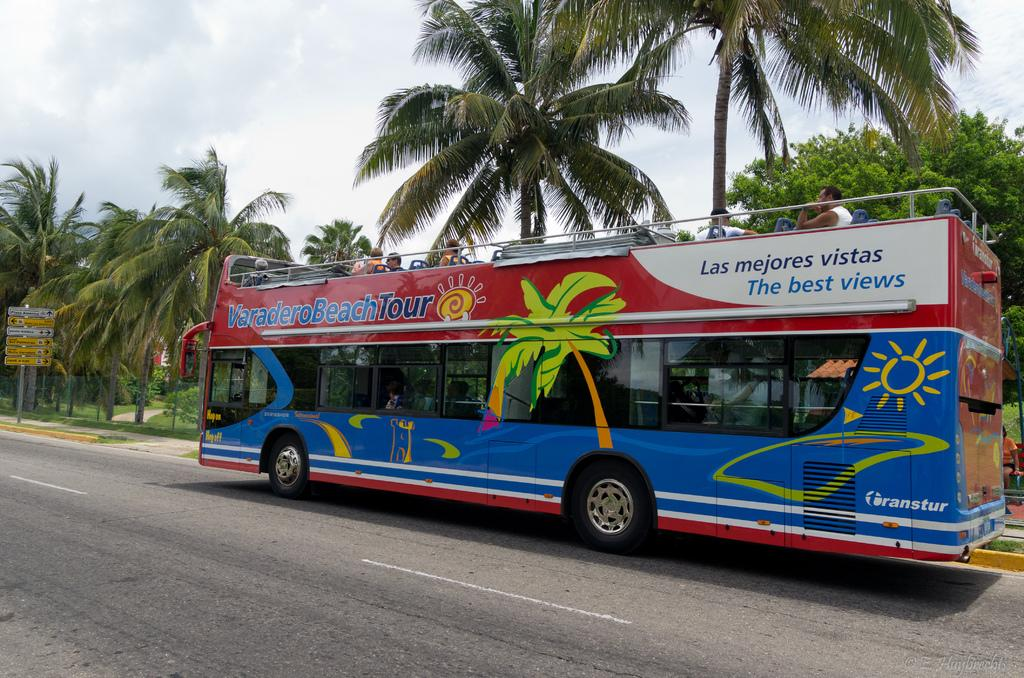<image>
Present a compact description of the photo's key features. A red and blue colored bus has the text the best views on the back side of it. 